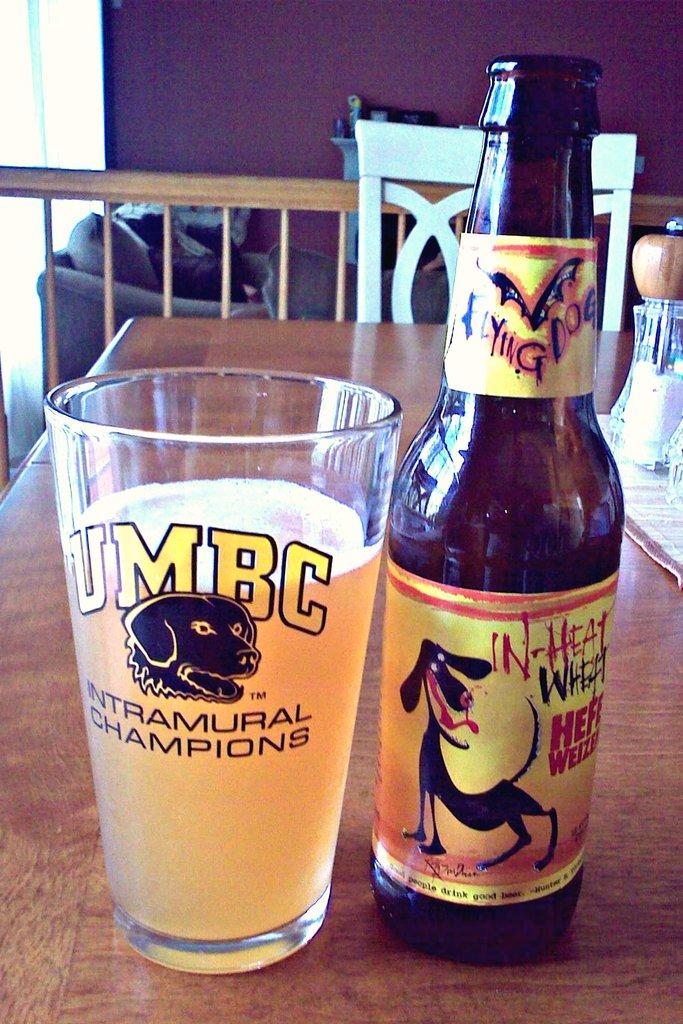<image>
Offer a succinct explanation of the picture presented. A bottle of Ying Dog beer is next to a glass of beer on a table. 